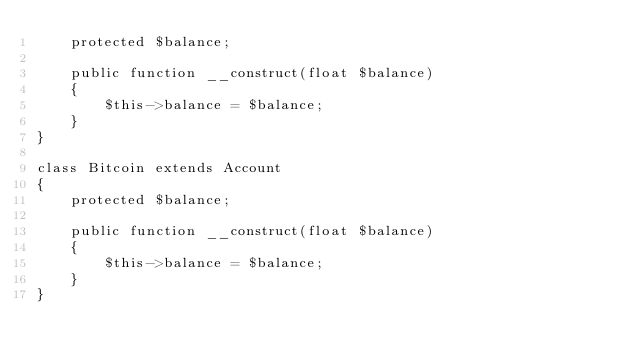<code> <loc_0><loc_0><loc_500><loc_500><_PHP_>    protected $balance;

    public function __construct(float $balance)
    {
        $this->balance = $balance;
    }
}

class Bitcoin extends Account
{
    protected $balance;

    public function __construct(float $balance)
    {
        $this->balance = $balance;
    }
}
</code> 